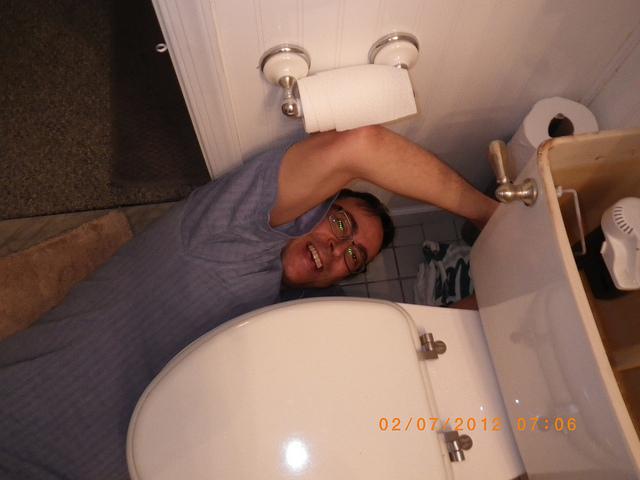What date was this photo taken?
Be succinct. 02/07/2012. Is the man using the toilet?
Concise answer only. No. What is hanging on a roll?
Keep it brief. Toilet paper. Is the man doing plumbing work?
Keep it brief. Yes. 